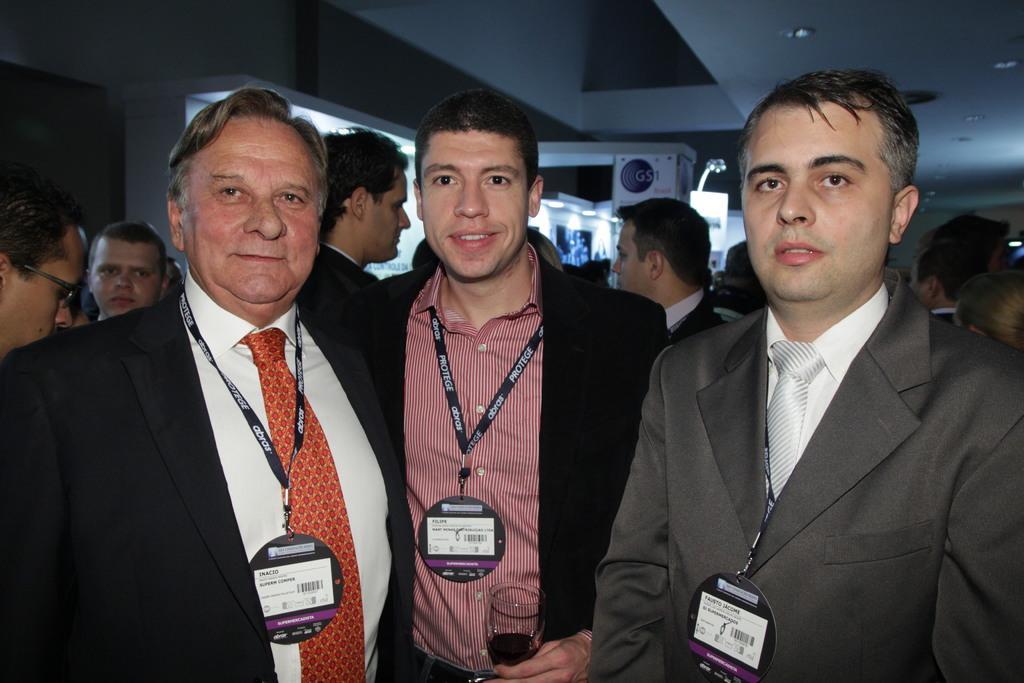Can you describe this image briefly? In the picture there are many people in a room, the first three people were posing for the photo, they are wearing blazers and id cards. The middle person is holding a glass with his hand. 